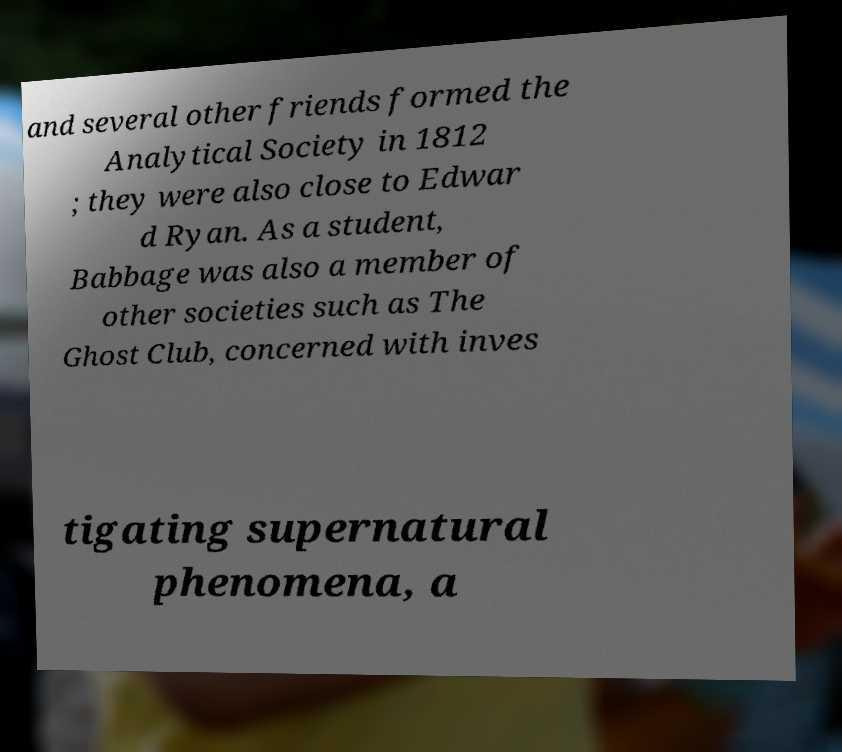Could you assist in decoding the text presented in this image and type it out clearly? and several other friends formed the Analytical Society in 1812 ; they were also close to Edwar d Ryan. As a student, Babbage was also a member of other societies such as The Ghost Club, concerned with inves tigating supernatural phenomena, a 